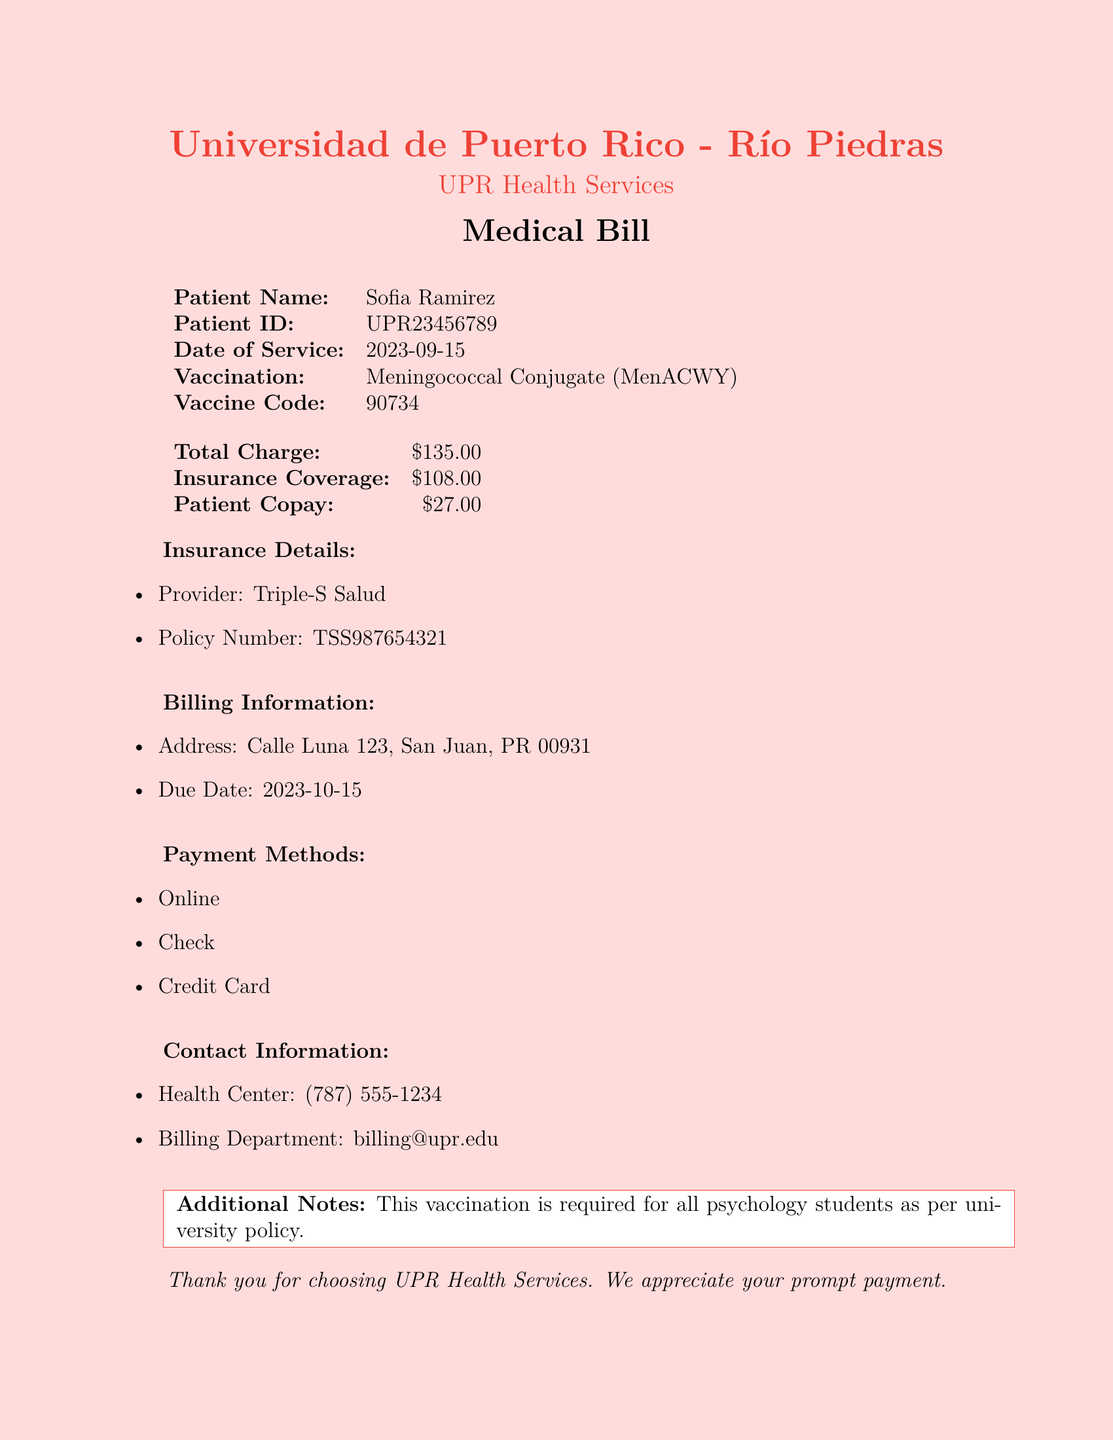What is the patient ID? The patient ID is found next to the patient's name in the document.
Answer: UPR23456789 What is the date of service? The date of service is located in the details of the vaccination provided.
Answer: 2023-09-15 What is the total charge for the vaccination? The total charge is explicitly mentioned in the billing section of the document.
Answer: $135.00 What is the insurance provider? The insurance provider is stated in the insurance details of the document.
Answer: Triple-S Salud How much is the patient copay? The patient copay is listed in the financial information section.
Answer: $27.00 What is the due date for payment? The due date is part of the billing information listed in the document.
Answer: 2023-10-15 Why was the vaccination required? The document specifies that the vaccination is mandatory for a certain student group as per policy.
Answer: For all psychology students What payment methods are accepted? Payment methods are listed in their own section, providing various options.
Answer: Online, Check, Credit Card What is the contact number for the health center? The contact number for the health center can be found in the contact information section.
Answer: (787) 555-1234 